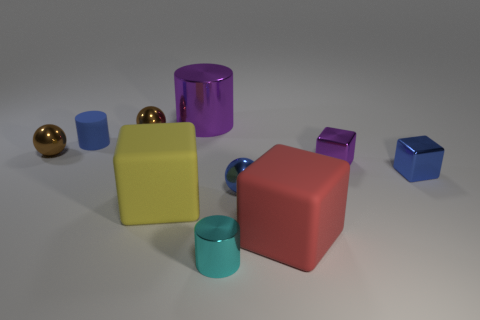Subtract all small cyan metal cylinders. How many cylinders are left? 2 Subtract all brown blocks. Subtract all gray cylinders. How many blocks are left? 4 Subtract all cylinders. How many objects are left? 7 Add 10 small gray objects. How many small gray objects exist? 10 Subtract 0 red spheres. How many objects are left? 10 Subtract all tiny cyan blocks. Subtract all brown balls. How many objects are left? 8 Add 1 tiny blue rubber cylinders. How many tiny blue rubber cylinders are left? 2 